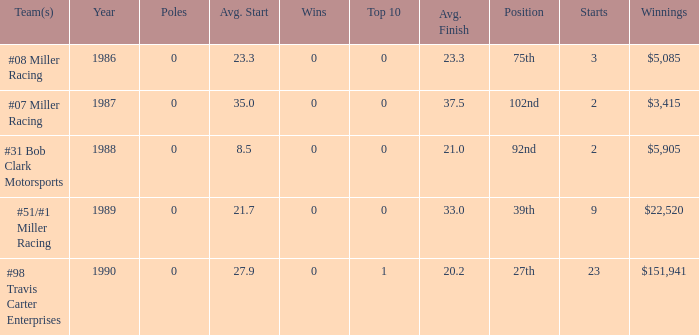What is the most recent year where the average start is 8.5? 1988.0. 